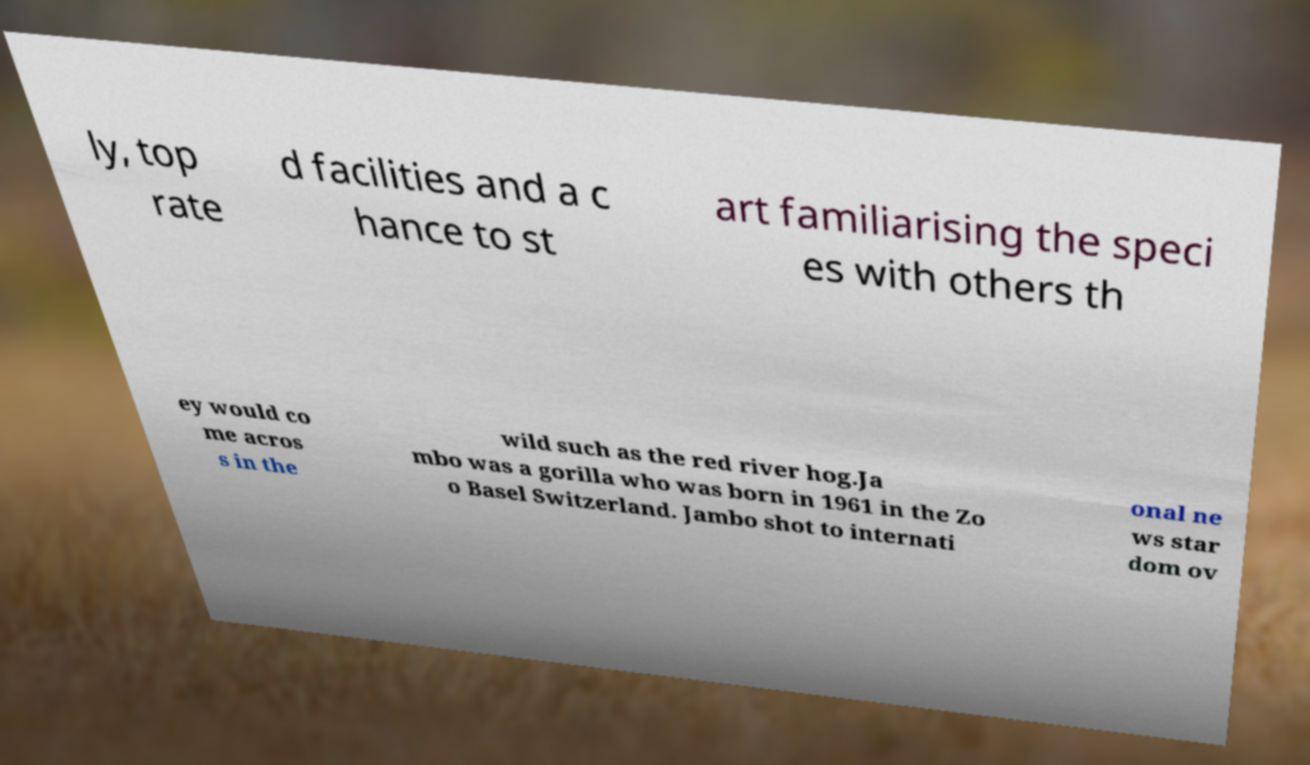For documentation purposes, I need the text within this image transcribed. Could you provide that? ly, top rate d facilities and a c hance to st art familiarising the speci es with others th ey would co me acros s in the wild such as the red river hog.Ja mbo was a gorilla who was born in 1961 in the Zo o Basel Switzerland. Jambo shot to internati onal ne ws star dom ov 